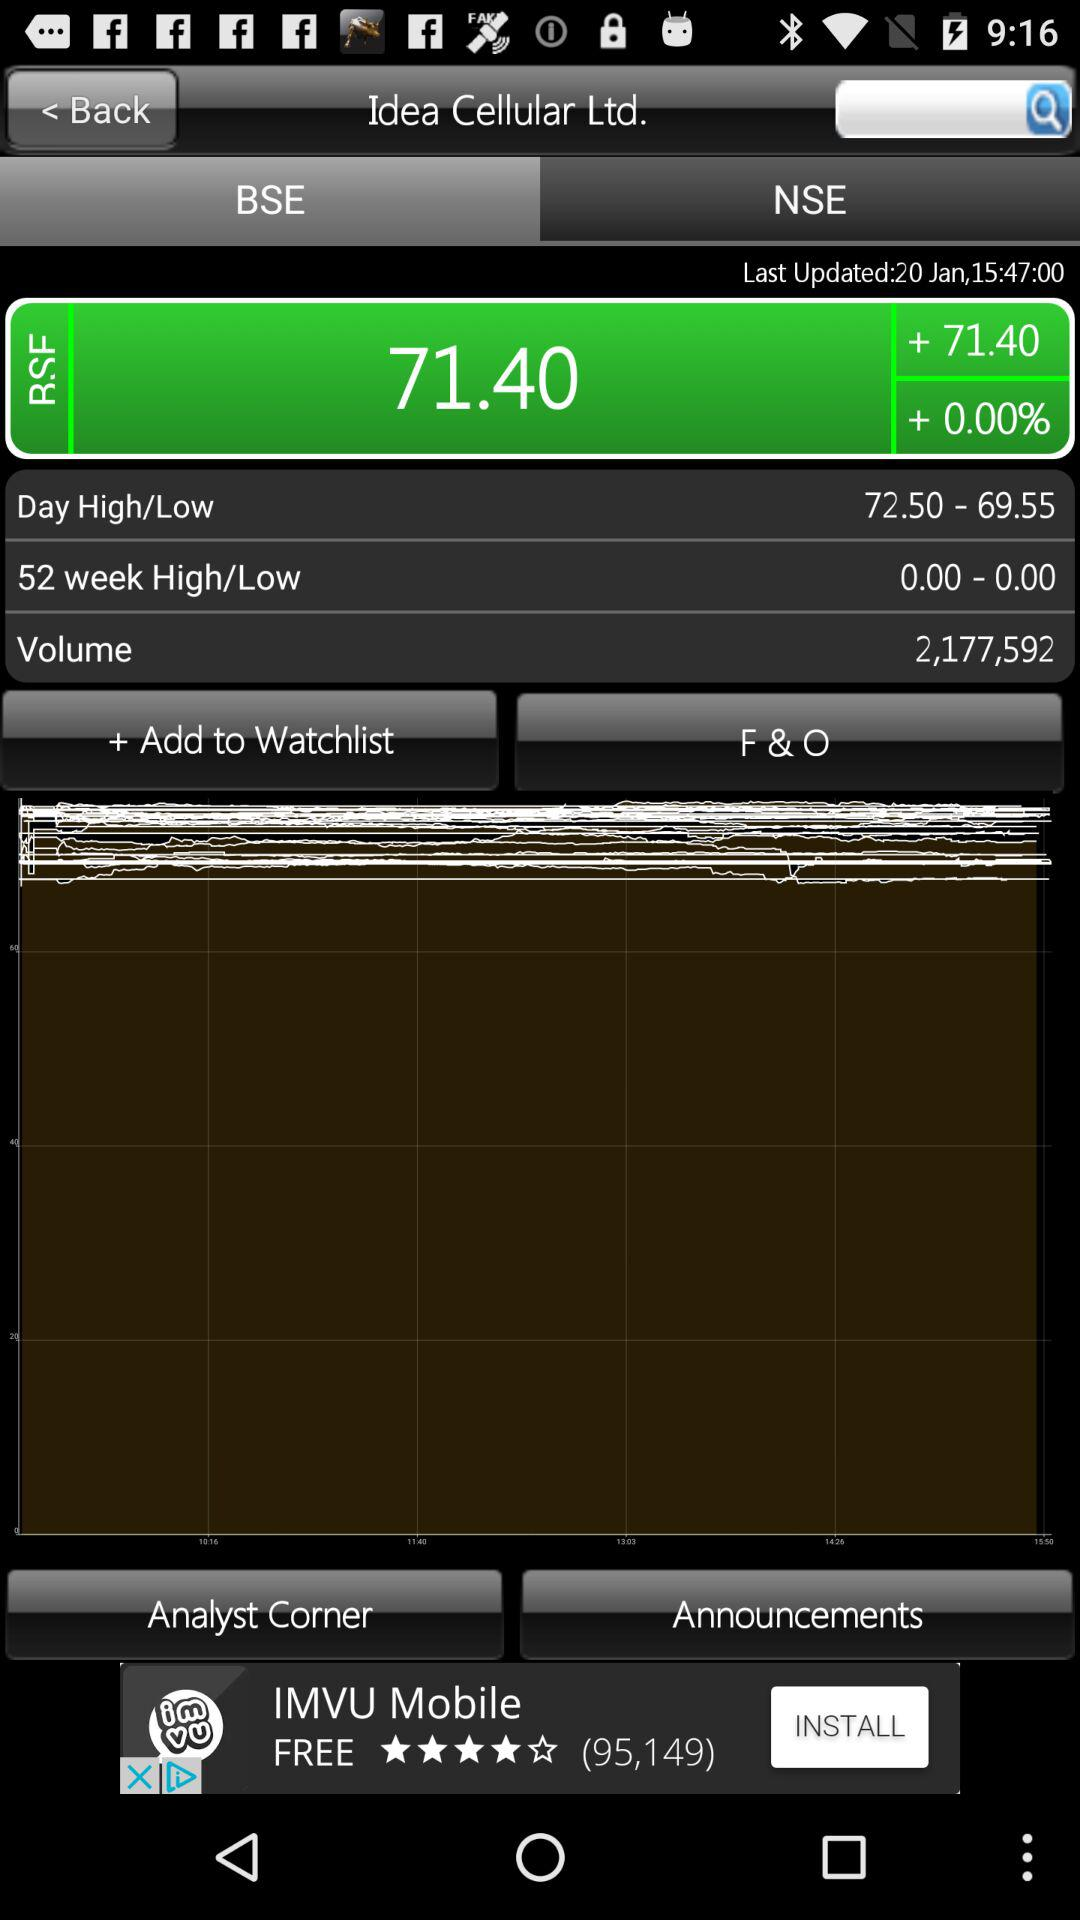On what date is the data updated? The data is updated on January 20. 